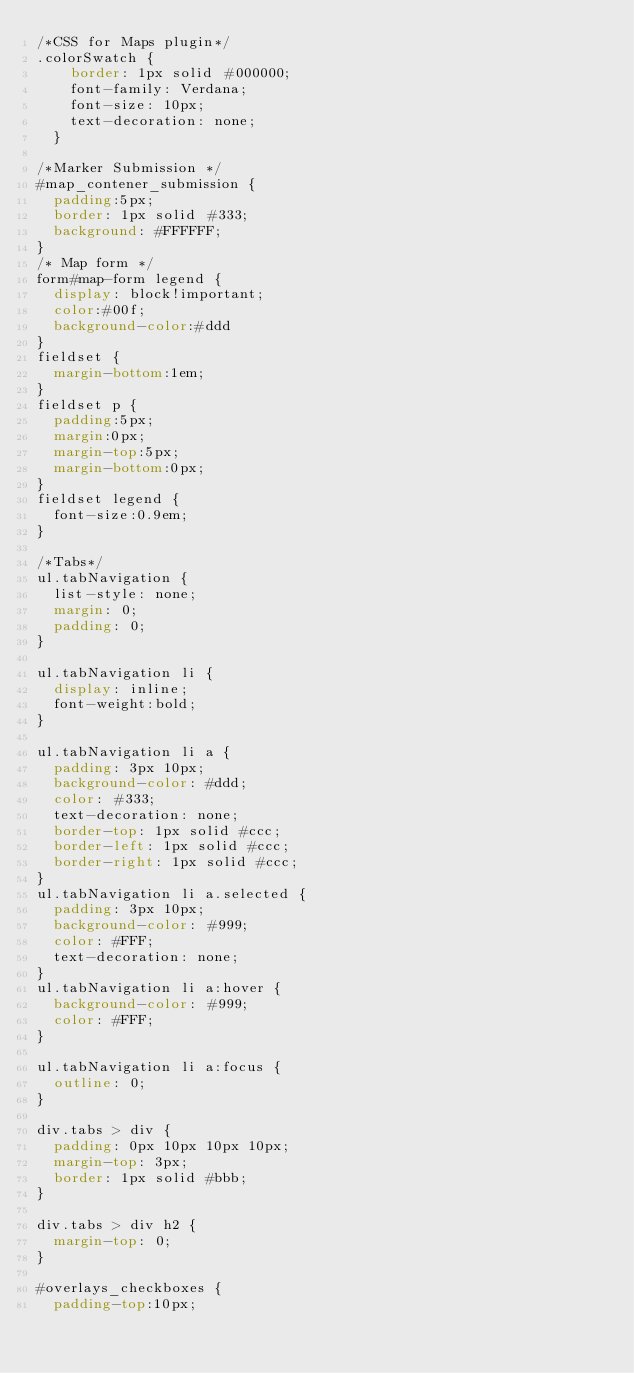Convert code to text. <code><loc_0><loc_0><loc_500><loc_500><_CSS_>/*CSS for Maps plugin*/
.colorSwatch {
    border: 1px solid #000000; 
    font-family: Verdana; 
    font-size: 10px; 
    text-decoration: none;
  }

/*Marker Submission */
#map_contener_submission {
	padding:5px;
	border: 1px solid #333;
	background: #FFFFFF;
}
/* Map form */
form#map-form legend {
  display: block!important;
  color:#00f;
  background-color:#ddd
}
fieldset {
  margin-bottom:1em;
}
fieldset p {
  padding:5px;
  margin:0px;
  margin-top:5px;
  margin-bottom:0px;
}
fieldset legend {
  font-size:0.9em;
}

/*Tabs*/
ul.tabNavigation {
  list-style: none;
  margin: 0;
  padding: 0;
}

ul.tabNavigation li {
  display: inline;
  font-weight:bold;
}

ul.tabNavigation li a {
  padding: 3px 10px;
  background-color: #ddd;
  color: #333;
  text-decoration: none;
  border-top: 1px solid #ccc;
  border-left: 1px solid #ccc;
  border-right: 1px solid #ccc;
}
ul.tabNavigation li a.selected {
  padding: 3px 10px;
  background-color: #999;
  color: #FFF;
  text-decoration: none;
}
ul.tabNavigation li a:hover {
  background-color: #999;
  color: #FFF;
}

ul.tabNavigation li a:focus {
  outline: 0;
}

div.tabs > div {
  padding: 0px 10px 10px 10px;
  margin-top: 3px;
  border: 1px solid #bbb;
}

div.tabs > div h2 {
  margin-top: 0;
}

#overlays_checkboxes {
  padding-top:10px;</code> 